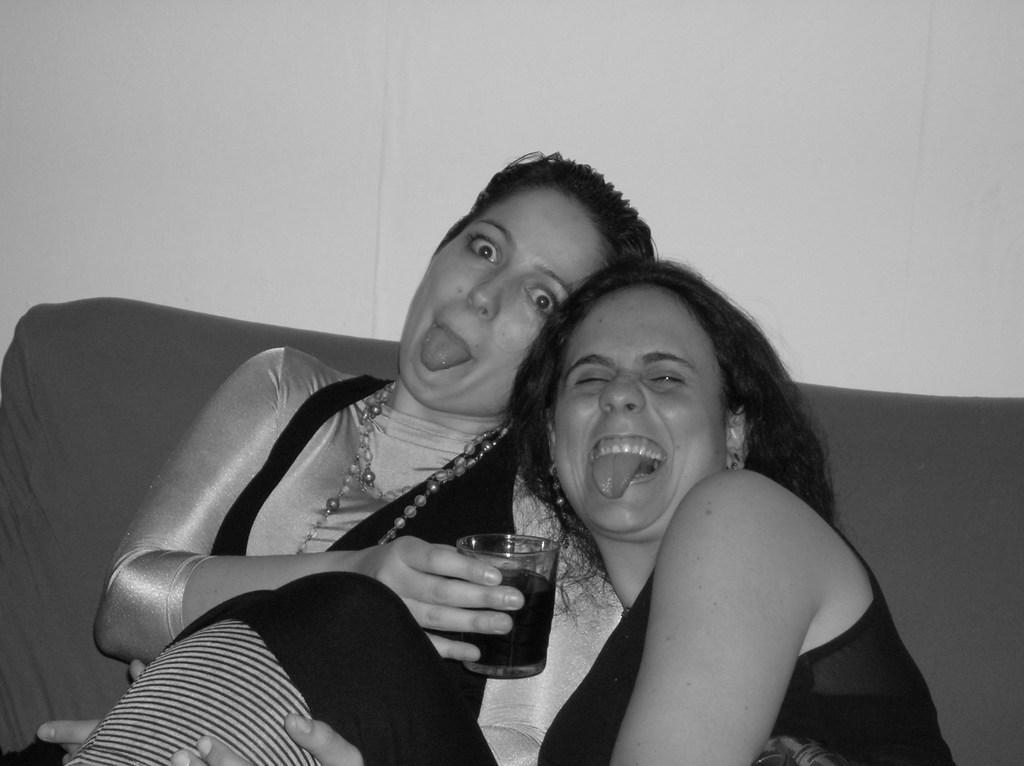In one or two sentences, can you explain what this image depicts? In this picture in the center there are women having some expressions on their faces. The woman on the left side is holding a glass. 